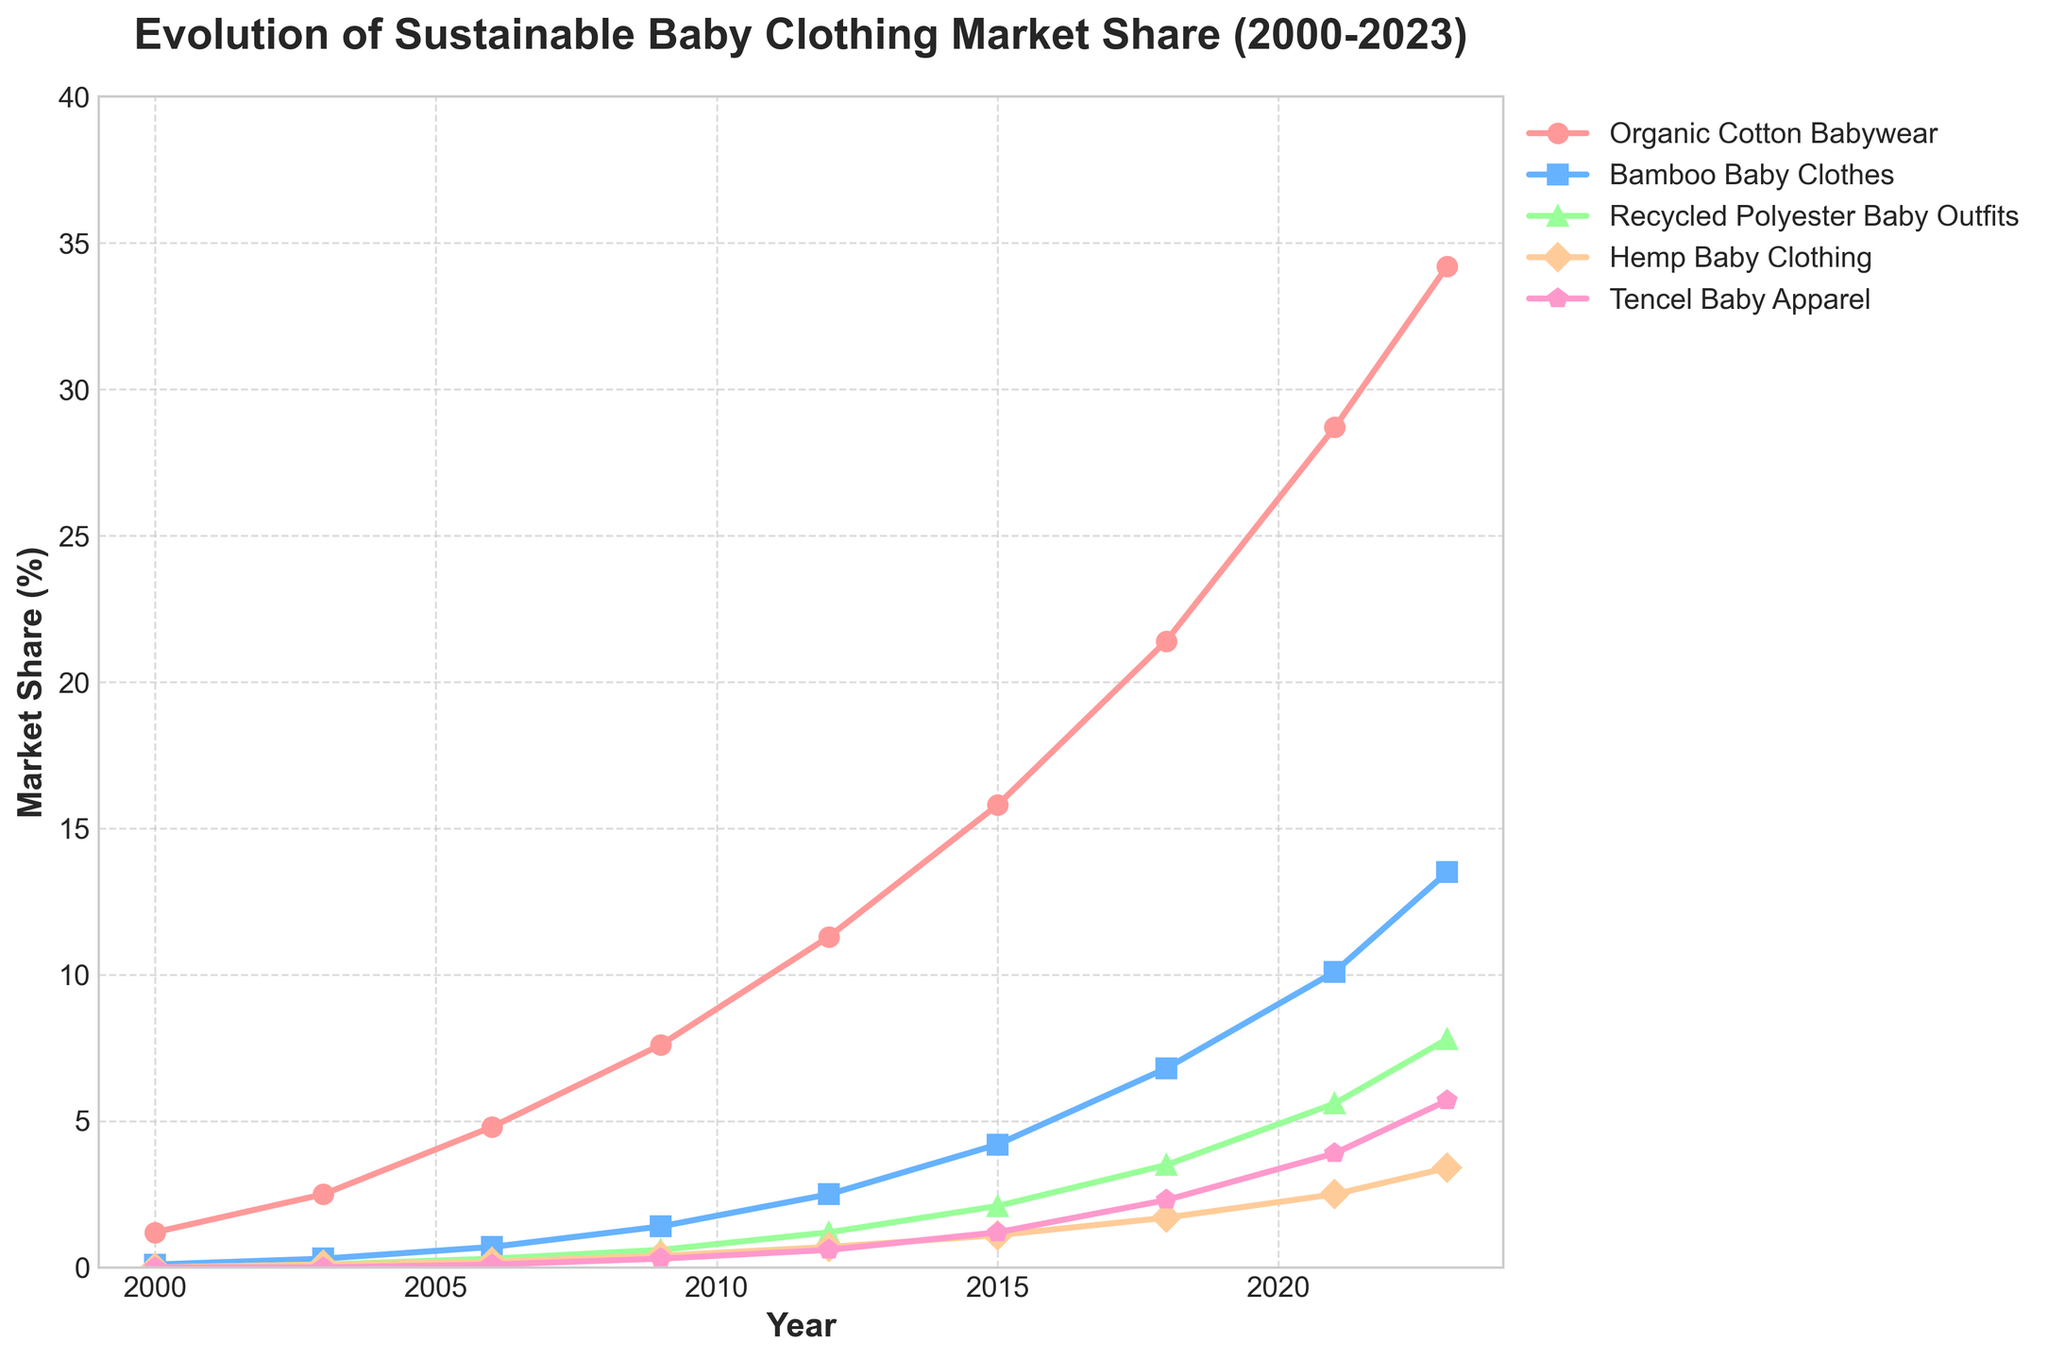When did Organic Cotton Babywear first reach a market share of over 10%? To find the answer, look at the line representing Organic Cotton Babywear and identify the year when it first surpasses the 10% mark. The line crosses the 10% mark between 2009 and 2012.
Answer: 2012 In 2021, which category had the second-highest market share? For the year 2021, observe all the lines and their respective positions. Organic Cotton Babywear had the highest market share, and Bamboo Baby Clothes follows with a close 10.1%.
Answer: Bamboo Baby Clothes By how much did the market share of Bamboo Baby Clothes increase between 2003 and 2015? Subtract the market share of Bamboo Baby Clothes in 2003 (0.3%) from its market share in 2015 (4.2%). 4.2% - 0.3% = 3.9%
Answer: 3.9% Which sustainable clothing category saw the most significant growth in market share from 2000 to 2023? Look at the starting and ending points of each line. The largest vertical difference indicates the most significant growth. Organic Cotton Babywear grew from 1.2% to 34.2%.
Answer: Organic Cotton Babywear In 2015, what is the combined market share of Recycled Polyester Baby Outfits and Hemp Baby Clothing? Add the market shares for Recycled Polyester Baby Outfits (2.1%) and Hemp Baby Clothing (1.1%) in 2015. 2.1% + 1.1% = 3.2%
Answer: 3.2% How did the market share of Tencel Baby Apparel change between 2000 and 2023? Compare the market share of Tencel Baby Apparel in 2000 (0.0%) to its market share in 2023 (5.7%). Calculate the difference. 5.7% - 0.0% = 5.7%
Answer: 5.7% By what percentage did the market share of Hemp Baby Clothing increase between 2009 and 2021? Find the market share of Hemp Baby Clothing in 2009 (0.4%) and 2021 (2.5%). Subtract to get the increase (2.5% - 0.4% = 2.1%), and then perform percentage calculation: (2.1% / 0.4%) * 100 = 525%
Answer: 525% Between 2006 and 2009, which clothing category saw the smallest increase in market share? Calculate the market share differences for each category between 2006 and 2009. The smallest increase is observed for Recycled Polyester Baby Outfits, growing from 0.3% to 0.6%, which is a 0.3% increase.
Answer: Recycled Polyester Baby Outfits Which category had the lowest market share continuously from 2000 to 2012? Identify the line that remained the lowest throughout the years from 2000 to 2012. Tencel Baby Apparel consistently had the lowest market share during this period.
Answer: Tencel Baby Apparel 